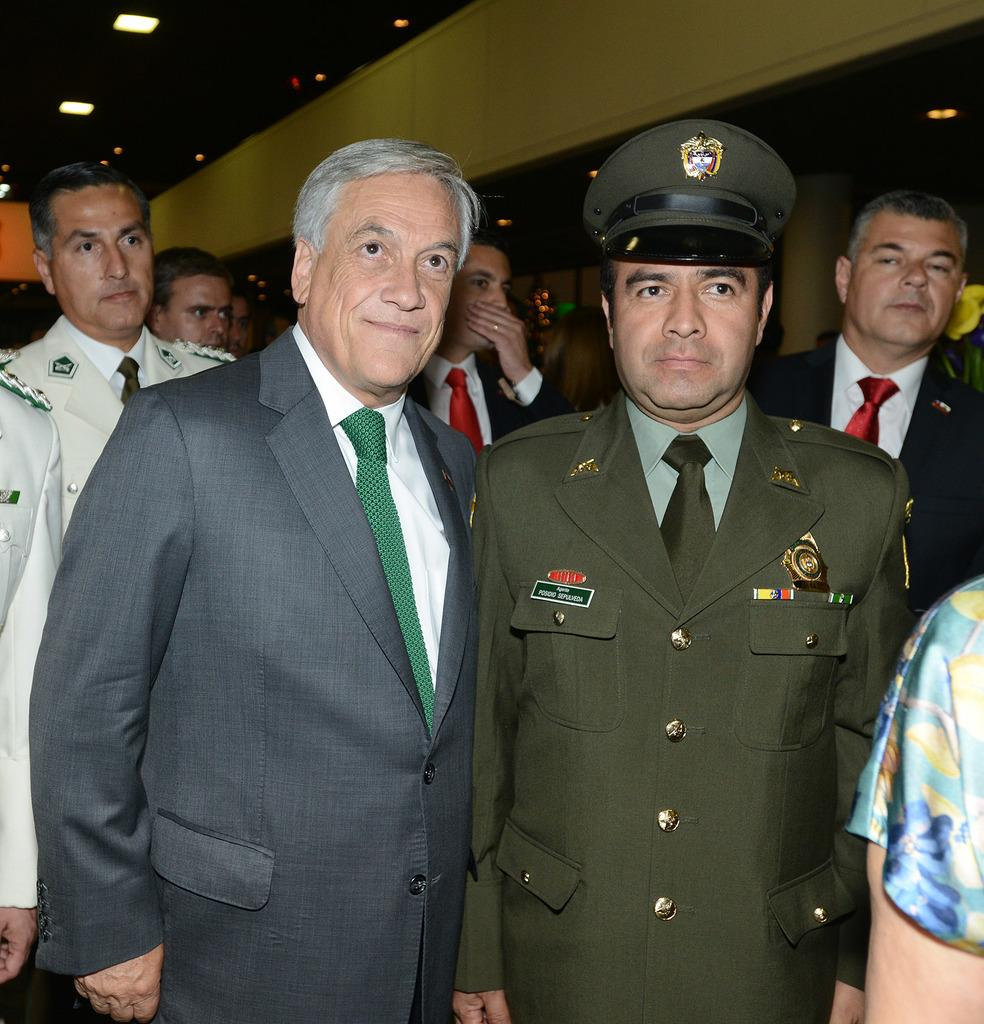How many people are in the image? There is a group of people in the image, but the exact number is not specified. What type of clothing are the people wearing? The people in the image are wearing blazers and ties. What can be seen in the background of the image? There are lights and pillars in the background of the image. What type of tomatoes are being used to decorate the pillars in the image? There are no tomatoes present in the image, and the pillars are not being decorated with any fruits or vegetables. 